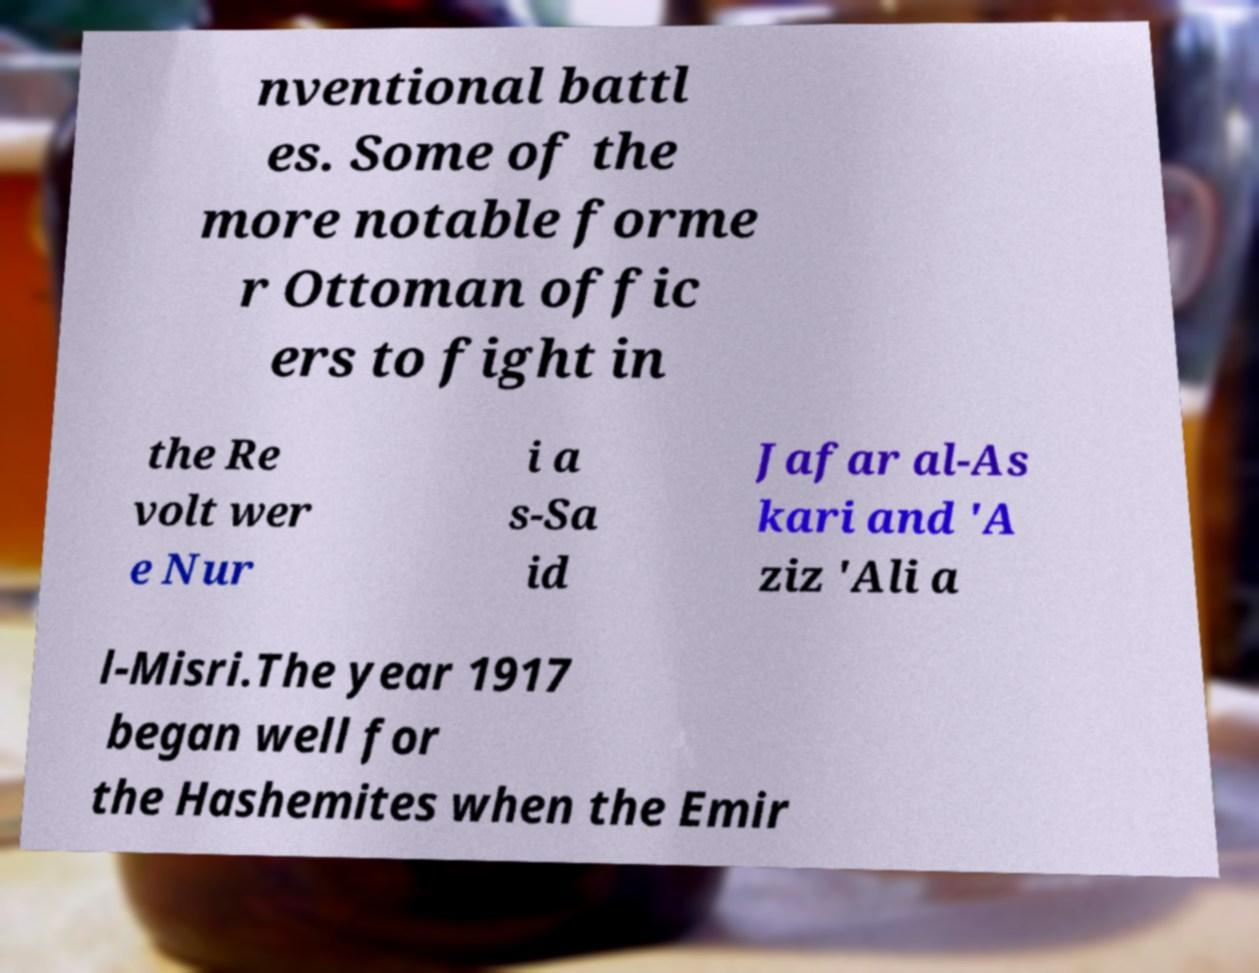I need the written content from this picture converted into text. Can you do that? nventional battl es. Some of the more notable forme r Ottoman offic ers to fight in the Re volt wer e Nur i a s-Sa id Jafar al-As kari and 'A ziz 'Ali a l-Misri.The year 1917 began well for the Hashemites when the Emir 